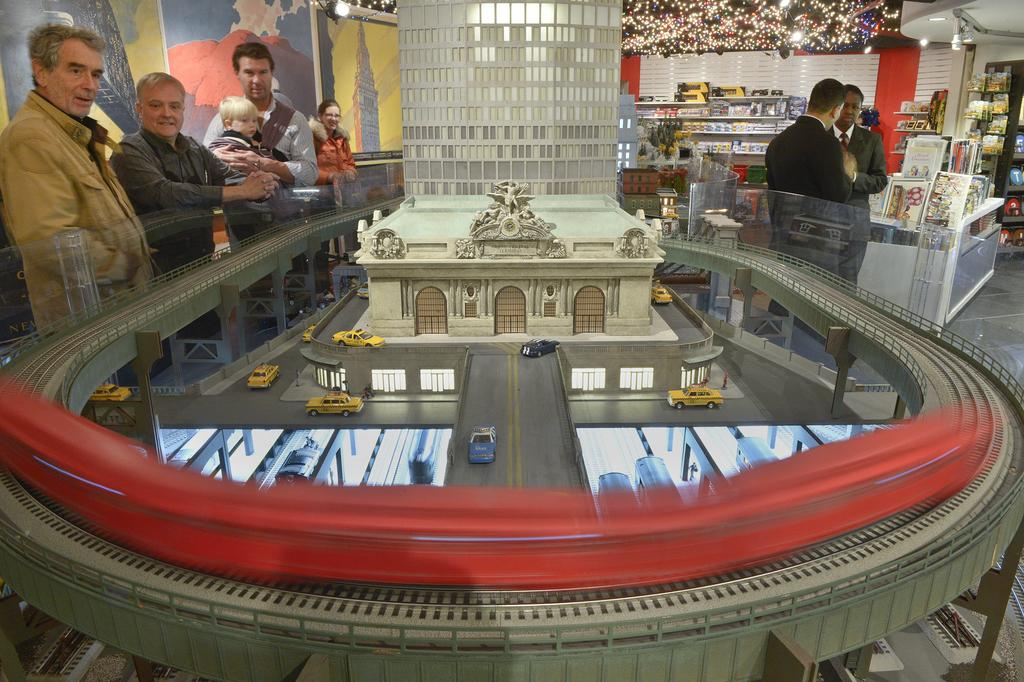What is present in the image involving human subjects? There are people standing in the image. What type of structure can be seen in the image? There is a building in the image. What mode of transportation can be seen on the road in the image? There are vehicles on the road in the image. Can you see an owl sitting on the seat of one of the vehicles in the image? There is no owl or seat visible in the image; it only features people, a building, and vehicles on the road. 